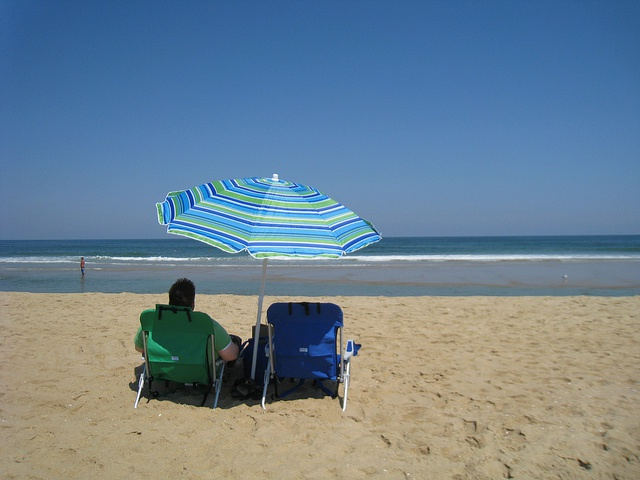Describe the objects in this image and their specific colors. I can see umbrella in blue, lightblue, and lightgray tones, chair in blue, navy, black, and darkgray tones, chair in blue, darkgreen, black, gray, and teal tones, people in blue, black, darkgreen, gray, and teal tones, and people in blue, gray, black, and maroon tones in this image. 